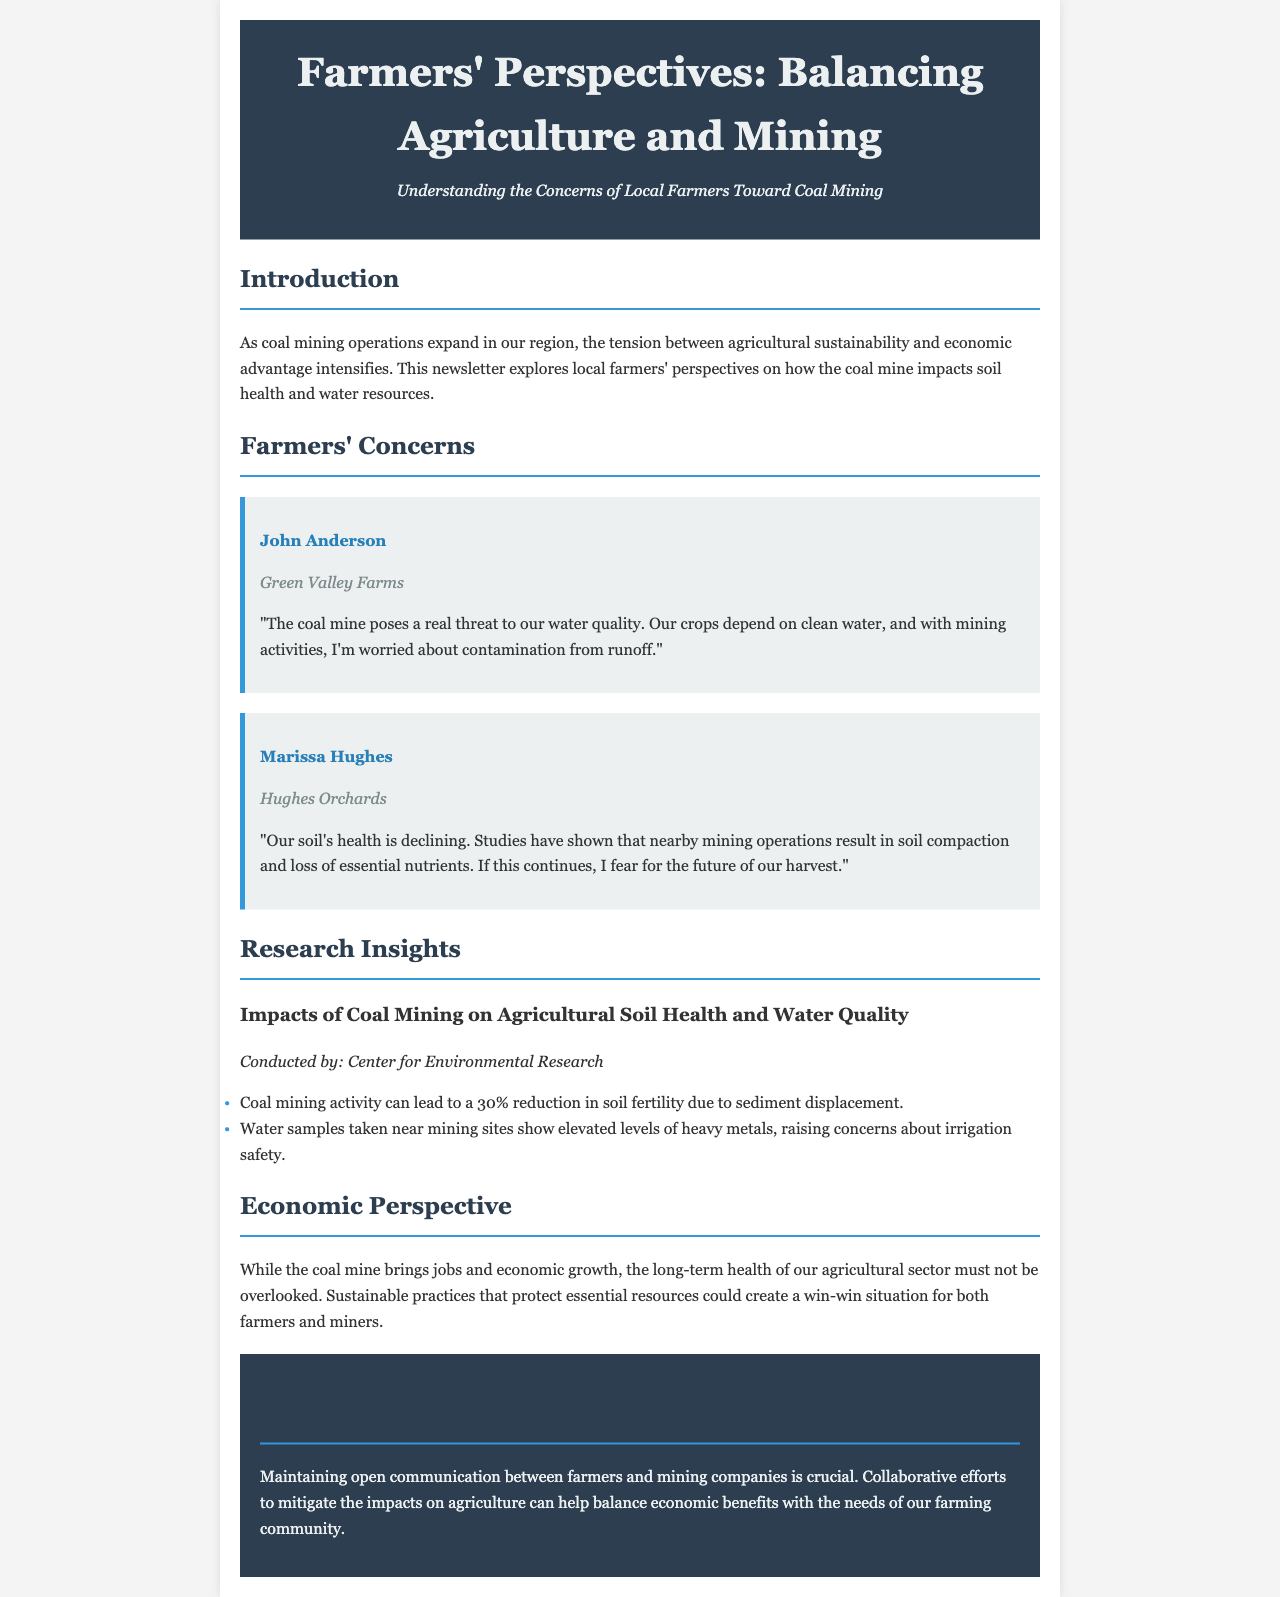What is the primary concern of John Anderson regarding the coal mine? John Anderson expresses concern about water quality and potential contamination from mining runoff.
Answer: Water quality What percentage reduction in soil fertility can occur due to coal mining activity? The document states that coal mining can lead to a 30% reduction in soil fertility.
Answer: 30% Which organization conducted the research on coal mining impacts? The research was conducted by the Center for Environmental Research.
Answer: Center for Environmental Research What problem is Marissa Hughes facing with her soil? Marissa Hughes is experiencing a decline in soil health, specifically regarding compaction and nutrient loss.
Answer: Soil health decline What potential benefits does the coal mine bring to the local economy? The coal mine provides jobs and economic growth in the area.
Answer: Jobs and economic growth How can a balance be achieved between farmers and mining companies? The document suggests that maintaining open communication and collaborative efforts could help balance the needs of both parties.
Answer: Open communication and collaboration 